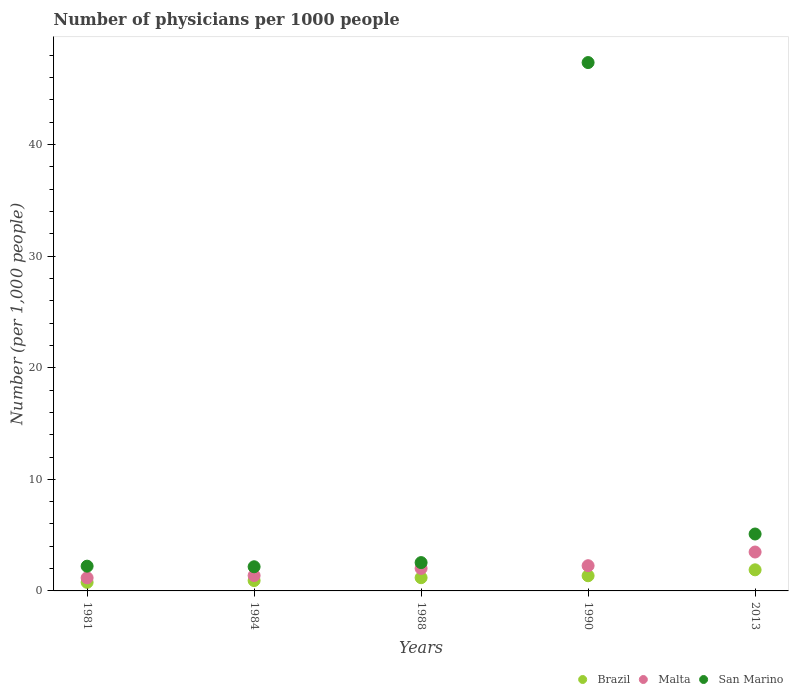Is the number of dotlines equal to the number of legend labels?
Your response must be concise. Yes. What is the number of physicians in San Marino in 1990?
Ensure brevity in your answer.  47.35. Across all years, what is the maximum number of physicians in Brazil?
Provide a short and direct response. 1.89. Across all years, what is the minimum number of physicians in San Marino?
Keep it short and to the point. 2.17. In which year was the number of physicians in Brazil minimum?
Offer a very short reply. 1981. What is the total number of physicians in San Marino in the graph?
Provide a succinct answer. 59.37. What is the difference between the number of physicians in Brazil in 1990 and that in 2013?
Keep it short and to the point. -0.53. What is the difference between the number of physicians in Malta in 1988 and the number of physicians in Brazil in 1981?
Your answer should be compact. 1.25. What is the average number of physicians in Malta per year?
Provide a short and direct response. 2.06. In the year 1988, what is the difference between the number of physicians in Malta and number of physicians in Brazil?
Ensure brevity in your answer.  0.83. What is the ratio of the number of physicians in Malta in 1984 to that in 2013?
Provide a succinct answer. 0.4. Is the number of physicians in San Marino in 1981 less than that in 2013?
Provide a succinct answer. Yes. What is the difference between the highest and the second highest number of physicians in San Marino?
Provide a succinct answer. 42.25. What is the difference between the highest and the lowest number of physicians in Brazil?
Your response must be concise. 1.12. In how many years, is the number of physicians in Malta greater than the average number of physicians in Malta taken over all years?
Offer a terse response. 2. Is the sum of the number of physicians in San Marino in 1988 and 1990 greater than the maximum number of physicians in Brazil across all years?
Keep it short and to the point. Yes. Is it the case that in every year, the sum of the number of physicians in San Marino and number of physicians in Brazil  is greater than the number of physicians in Malta?
Ensure brevity in your answer.  Yes. How many dotlines are there?
Provide a succinct answer. 3. What is the difference between two consecutive major ticks on the Y-axis?
Your response must be concise. 10. Are the values on the major ticks of Y-axis written in scientific E-notation?
Make the answer very short. No. Where does the legend appear in the graph?
Offer a very short reply. Bottom right. How many legend labels are there?
Your answer should be very brief. 3. What is the title of the graph?
Your answer should be compact. Number of physicians per 1000 people. Does "Bolivia" appear as one of the legend labels in the graph?
Provide a succinct answer. No. What is the label or title of the X-axis?
Provide a short and direct response. Years. What is the label or title of the Y-axis?
Provide a succinct answer. Number (per 1,0 people). What is the Number (per 1,000 people) of Brazil in 1981?
Offer a very short reply. 0.77. What is the Number (per 1,000 people) in Malta in 1981?
Offer a very short reply. 1.17. What is the Number (per 1,000 people) of San Marino in 1981?
Give a very brief answer. 2.22. What is the Number (per 1,000 people) in Brazil in 1984?
Your answer should be compact. 0.93. What is the Number (per 1,000 people) in Malta in 1984?
Keep it short and to the point. 1.38. What is the Number (per 1,000 people) of San Marino in 1984?
Provide a short and direct response. 2.17. What is the Number (per 1,000 people) in Brazil in 1988?
Offer a very short reply. 1.19. What is the Number (per 1,000 people) of Malta in 1988?
Your response must be concise. 2.02. What is the Number (per 1,000 people) of San Marino in 1988?
Your answer should be compact. 2.54. What is the Number (per 1,000 people) of Brazil in 1990?
Give a very brief answer. 1.36. What is the Number (per 1,000 people) in Malta in 1990?
Offer a terse response. 2.26. What is the Number (per 1,000 people) in San Marino in 1990?
Provide a succinct answer. 47.35. What is the Number (per 1,000 people) of Brazil in 2013?
Your answer should be compact. 1.89. What is the Number (per 1,000 people) of Malta in 2013?
Your answer should be compact. 3.49. Across all years, what is the maximum Number (per 1,000 people) in Brazil?
Your answer should be compact. 1.89. Across all years, what is the maximum Number (per 1,000 people) of Malta?
Make the answer very short. 3.49. Across all years, what is the maximum Number (per 1,000 people) of San Marino?
Your response must be concise. 47.35. Across all years, what is the minimum Number (per 1,000 people) in Brazil?
Make the answer very short. 0.77. Across all years, what is the minimum Number (per 1,000 people) in Malta?
Provide a short and direct response. 1.17. Across all years, what is the minimum Number (per 1,000 people) in San Marino?
Provide a succinct answer. 2.17. What is the total Number (per 1,000 people) in Brazil in the graph?
Your response must be concise. 6.13. What is the total Number (per 1,000 people) in Malta in the graph?
Your answer should be compact. 10.31. What is the total Number (per 1,000 people) of San Marino in the graph?
Your answer should be very brief. 59.37. What is the difference between the Number (per 1,000 people) of Brazil in 1981 and that in 1984?
Make the answer very short. -0.16. What is the difference between the Number (per 1,000 people) of Malta in 1981 and that in 1984?
Your answer should be very brief. -0.21. What is the difference between the Number (per 1,000 people) of San Marino in 1981 and that in 1984?
Make the answer very short. 0.05. What is the difference between the Number (per 1,000 people) of Brazil in 1981 and that in 1988?
Offer a very short reply. -0.42. What is the difference between the Number (per 1,000 people) of Malta in 1981 and that in 1988?
Provide a short and direct response. -0.84. What is the difference between the Number (per 1,000 people) of San Marino in 1981 and that in 1988?
Offer a terse response. -0.32. What is the difference between the Number (per 1,000 people) of Brazil in 1981 and that in 1990?
Keep it short and to the point. -0.59. What is the difference between the Number (per 1,000 people) of Malta in 1981 and that in 1990?
Provide a short and direct response. -1.09. What is the difference between the Number (per 1,000 people) of San Marino in 1981 and that in 1990?
Provide a succinct answer. -45.13. What is the difference between the Number (per 1,000 people) of Brazil in 1981 and that in 2013?
Your response must be concise. -1.12. What is the difference between the Number (per 1,000 people) in Malta in 1981 and that in 2013?
Provide a short and direct response. -2.31. What is the difference between the Number (per 1,000 people) in San Marino in 1981 and that in 2013?
Provide a succinct answer. -2.88. What is the difference between the Number (per 1,000 people) of Brazil in 1984 and that in 1988?
Provide a short and direct response. -0.26. What is the difference between the Number (per 1,000 people) of Malta in 1984 and that in 1988?
Make the answer very short. -0.64. What is the difference between the Number (per 1,000 people) of San Marino in 1984 and that in 1988?
Offer a terse response. -0.37. What is the difference between the Number (per 1,000 people) in Brazil in 1984 and that in 1990?
Provide a succinct answer. -0.43. What is the difference between the Number (per 1,000 people) of Malta in 1984 and that in 1990?
Provide a succinct answer. -0.88. What is the difference between the Number (per 1,000 people) of San Marino in 1984 and that in 1990?
Your answer should be compact. -45.18. What is the difference between the Number (per 1,000 people) in Brazil in 1984 and that in 2013?
Ensure brevity in your answer.  -0.96. What is the difference between the Number (per 1,000 people) in Malta in 1984 and that in 2013?
Your answer should be very brief. -2.11. What is the difference between the Number (per 1,000 people) of San Marino in 1984 and that in 2013?
Keep it short and to the point. -2.93. What is the difference between the Number (per 1,000 people) in Brazil in 1988 and that in 1990?
Provide a succinct answer. -0.17. What is the difference between the Number (per 1,000 people) in Malta in 1988 and that in 1990?
Provide a short and direct response. -0.24. What is the difference between the Number (per 1,000 people) in San Marino in 1988 and that in 1990?
Your answer should be very brief. -44.81. What is the difference between the Number (per 1,000 people) of Brazil in 1988 and that in 2013?
Give a very brief answer. -0.71. What is the difference between the Number (per 1,000 people) of Malta in 1988 and that in 2013?
Offer a very short reply. -1.47. What is the difference between the Number (per 1,000 people) of San Marino in 1988 and that in 2013?
Your answer should be very brief. -2.56. What is the difference between the Number (per 1,000 people) in Brazil in 1990 and that in 2013?
Ensure brevity in your answer.  -0.53. What is the difference between the Number (per 1,000 people) of Malta in 1990 and that in 2013?
Give a very brief answer. -1.23. What is the difference between the Number (per 1,000 people) in San Marino in 1990 and that in 2013?
Your answer should be very brief. 42.25. What is the difference between the Number (per 1,000 people) in Brazil in 1981 and the Number (per 1,000 people) in Malta in 1984?
Your response must be concise. -0.61. What is the difference between the Number (per 1,000 people) of Brazil in 1981 and the Number (per 1,000 people) of San Marino in 1984?
Make the answer very short. -1.4. What is the difference between the Number (per 1,000 people) of Malta in 1981 and the Number (per 1,000 people) of San Marino in 1984?
Offer a very short reply. -0.99. What is the difference between the Number (per 1,000 people) in Brazil in 1981 and the Number (per 1,000 people) in Malta in 1988?
Make the answer very short. -1.25. What is the difference between the Number (per 1,000 people) in Brazil in 1981 and the Number (per 1,000 people) in San Marino in 1988?
Keep it short and to the point. -1.77. What is the difference between the Number (per 1,000 people) in Malta in 1981 and the Number (per 1,000 people) in San Marino in 1988?
Provide a succinct answer. -1.37. What is the difference between the Number (per 1,000 people) of Brazil in 1981 and the Number (per 1,000 people) of Malta in 1990?
Keep it short and to the point. -1.49. What is the difference between the Number (per 1,000 people) of Brazil in 1981 and the Number (per 1,000 people) of San Marino in 1990?
Your response must be concise. -46.58. What is the difference between the Number (per 1,000 people) of Malta in 1981 and the Number (per 1,000 people) of San Marino in 1990?
Your answer should be compact. -46.18. What is the difference between the Number (per 1,000 people) of Brazil in 1981 and the Number (per 1,000 people) of Malta in 2013?
Your answer should be very brief. -2.72. What is the difference between the Number (per 1,000 people) in Brazil in 1981 and the Number (per 1,000 people) in San Marino in 2013?
Ensure brevity in your answer.  -4.33. What is the difference between the Number (per 1,000 people) in Malta in 1981 and the Number (per 1,000 people) in San Marino in 2013?
Offer a terse response. -3.93. What is the difference between the Number (per 1,000 people) of Brazil in 1984 and the Number (per 1,000 people) of Malta in 1988?
Make the answer very short. -1.09. What is the difference between the Number (per 1,000 people) of Brazil in 1984 and the Number (per 1,000 people) of San Marino in 1988?
Offer a terse response. -1.61. What is the difference between the Number (per 1,000 people) in Malta in 1984 and the Number (per 1,000 people) in San Marino in 1988?
Keep it short and to the point. -1.16. What is the difference between the Number (per 1,000 people) in Brazil in 1984 and the Number (per 1,000 people) in Malta in 1990?
Offer a very short reply. -1.33. What is the difference between the Number (per 1,000 people) in Brazil in 1984 and the Number (per 1,000 people) in San Marino in 1990?
Your answer should be compact. -46.42. What is the difference between the Number (per 1,000 people) of Malta in 1984 and the Number (per 1,000 people) of San Marino in 1990?
Provide a short and direct response. -45.97. What is the difference between the Number (per 1,000 people) in Brazil in 1984 and the Number (per 1,000 people) in Malta in 2013?
Provide a succinct answer. -2.56. What is the difference between the Number (per 1,000 people) of Brazil in 1984 and the Number (per 1,000 people) of San Marino in 2013?
Your answer should be compact. -4.17. What is the difference between the Number (per 1,000 people) in Malta in 1984 and the Number (per 1,000 people) in San Marino in 2013?
Your answer should be compact. -3.72. What is the difference between the Number (per 1,000 people) of Brazil in 1988 and the Number (per 1,000 people) of Malta in 1990?
Keep it short and to the point. -1.07. What is the difference between the Number (per 1,000 people) in Brazil in 1988 and the Number (per 1,000 people) in San Marino in 1990?
Offer a terse response. -46.16. What is the difference between the Number (per 1,000 people) of Malta in 1988 and the Number (per 1,000 people) of San Marino in 1990?
Your response must be concise. -45.34. What is the difference between the Number (per 1,000 people) of Brazil in 1988 and the Number (per 1,000 people) of Malta in 2013?
Your response must be concise. -2.3. What is the difference between the Number (per 1,000 people) of Brazil in 1988 and the Number (per 1,000 people) of San Marino in 2013?
Make the answer very short. -3.91. What is the difference between the Number (per 1,000 people) of Malta in 1988 and the Number (per 1,000 people) of San Marino in 2013?
Give a very brief answer. -3.08. What is the difference between the Number (per 1,000 people) in Brazil in 1990 and the Number (per 1,000 people) in Malta in 2013?
Your answer should be compact. -2.13. What is the difference between the Number (per 1,000 people) in Brazil in 1990 and the Number (per 1,000 people) in San Marino in 2013?
Your answer should be very brief. -3.74. What is the difference between the Number (per 1,000 people) of Malta in 1990 and the Number (per 1,000 people) of San Marino in 2013?
Give a very brief answer. -2.84. What is the average Number (per 1,000 people) of Brazil per year?
Ensure brevity in your answer.  1.23. What is the average Number (per 1,000 people) of Malta per year?
Your response must be concise. 2.06. What is the average Number (per 1,000 people) in San Marino per year?
Offer a very short reply. 11.87. In the year 1981, what is the difference between the Number (per 1,000 people) of Brazil and Number (per 1,000 people) of Malta?
Give a very brief answer. -0.4. In the year 1981, what is the difference between the Number (per 1,000 people) of Brazil and Number (per 1,000 people) of San Marino?
Offer a terse response. -1.45. In the year 1981, what is the difference between the Number (per 1,000 people) of Malta and Number (per 1,000 people) of San Marino?
Provide a succinct answer. -1.05. In the year 1984, what is the difference between the Number (per 1,000 people) of Brazil and Number (per 1,000 people) of Malta?
Keep it short and to the point. -0.45. In the year 1984, what is the difference between the Number (per 1,000 people) in Brazil and Number (per 1,000 people) in San Marino?
Your response must be concise. -1.24. In the year 1984, what is the difference between the Number (per 1,000 people) in Malta and Number (per 1,000 people) in San Marino?
Your answer should be very brief. -0.79. In the year 1988, what is the difference between the Number (per 1,000 people) of Brazil and Number (per 1,000 people) of Malta?
Make the answer very short. -0.83. In the year 1988, what is the difference between the Number (per 1,000 people) in Brazil and Number (per 1,000 people) in San Marino?
Give a very brief answer. -1.35. In the year 1988, what is the difference between the Number (per 1,000 people) of Malta and Number (per 1,000 people) of San Marino?
Keep it short and to the point. -0.52. In the year 1990, what is the difference between the Number (per 1,000 people) in Brazil and Number (per 1,000 people) in Malta?
Make the answer very short. -0.9. In the year 1990, what is the difference between the Number (per 1,000 people) in Brazil and Number (per 1,000 people) in San Marino?
Ensure brevity in your answer.  -45.99. In the year 1990, what is the difference between the Number (per 1,000 people) in Malta and Number (per 1,000 people) in San Marino?
Provide a short and direct response. -45.09. In the year 2013, what is the difference between the Number (per 1,000 people) of Brazil and Number (per 1,000 people) of Malta?
Give a very brief answer. -1.59. In the year 2013, what is the difference between the Number (per 1,000 people) in Brazil and Number (per 1,000 people) in San Marino?
Keep it short and to the point. -3.21. In the year 2013, what is the difference between the Number (per 1,000 people) of Malta and Number (per 1,000 people) of San Marino?
Provide a short and direct response. -1.61. What is the ratio of the Number (per 1,000 people) in Brazil in 1981 to that in 1984?
Provide a short and direct response. 0.83. What is the ratio of the Number (per 1,000 people) of Malta in 1981 to that in 1984?
Your response must be concise. 0.85. What is the ratio of the Number (per 1,000 people) of Brazil in 1981 to that in 1988?
Keep it short and to the point. 0.65. What is the ratio of the Number (per 1,000 people) of Malta in 1981 to that in 1988?
Your response must be concise. 0.58. What is the ratio of the Number (per 1,000 people) in San Marino in 1981 to that in 1988?
Your response must be concise. 0.87. What is the ratio of the Number (per 1,000 people) in Brazil in 1981 to that in 1990?
Your answer should be compact. 0.56. What is the ratio of the Number (per 1,000 people) in Malta in 1981 to that in 1990?
Give a very brief answer. 0.52. What is the ratio of the Number (per 1,000 people) of San Marino in 1981 to that in 1990?
Your answer should be compact. 0.05. What is the ratio of the Number (per 1,000 people) in Brazil in 1981 to that in 2013?
Make the answer very short. 0.41. What is the ratio of the Number (per 1,000 people) in Malta in 1981 to that in 2013?
Make the answer very short. 0.34. What is the ratio of the Number (per 1,000 people) in San Marino in 1981 to that in 2013?
Give a very brief answer. 0.43. What is the ratio of the Number (per 1,000 people) in Brazil in 1984 to that in 1988?
Your answer should be very brief. 0.78. What is the ratio of the Number (per 1,000 people) in Malta in 1984 to that in 1988?
Give a very brief answer. 0.68. What is the ratio of the Number (per 1,000 people) of San Marino in 1984 to that in 1988?
Ensure brevity in your answer.  0.85. What is the ratio of the Number (per 1,000 people) of Brazil in 1984 to that in 1990?
Give a very brief answer. 0.68. What is the ratio of the Number (per 1,000 people) in Malta in 1984 to that in 1990?
Ensure brevity in your answer.  0.61. What is the ratio of the Number (per 1,000 people) of San Marino in 1984 to that in 1990?
Offer a very short reply. 0.05. What is the ratio of the Number (per 1,000 people) in Brazil in 1984 to that in 2013?
Keep it short and to the point. 0.49. What is the ratio of the Number (per 1,000 people) in Malta in 1984 to that in 2013?
Offer a terse response. 0.4. What is the ratio of the Number (per 1,000 people) of San Marino in 1984 to that in 2013?
Your response must be concise. 0.42. What is the ratio of the Number (per 1,000 people) in Brazil in 1988 to that in 1990?
Offer a very short reply. 0.87. What is the ratio of the Number (per 1,000 people) in Malta in 1988 to that in 1990?
Give a very brief answer. 0.89. What is the ratio of the Number (per 1,000 people) of San Marino in 1988 to that in 1990?
Your answer should be compact. 0.05. What is the ratio of the Number (per 1,000 people) in Brazil in 1988 to that in 2013?
Make the answer very short. 0.63. What is the ratio of the Number (per 1,000 people) of Malta in 1988 to that in 2013?
Provide a short and direct response. 0.58. What is the ratio of the Number (per 1,000 people) of San Marino in 1988 to that in 2013?
Your response must be concise. 0.5. What is the ratio of the Number (per 1,000 people) of Brazil in 1990 to that in 2013?
Provide a succinct answer. 0.72. What is the ratio of the Number (per 1,000 people) of Malta in 1990 to that in 2013?
Your answer should be compact. 0.65. What is the ratio of the Number (per 1,000 people) in San Marino in 1990 to that in 2013?
Provide a succinct answer. 9.28. What is the difference between the highest and the second highest Number (per 1,000 people) of Brazil?
Your answer should be compact. 0.53. What is the difference between the highest and the second highest Number (per 1,000 people) of Malta?
Offer a very short reply. 1.23. What is the difference between the highest and the second highest Number (per 1,000 people) of San Marino?
Ensure brevity in your answer.  42.25. What is the difference between the highest and the lowest Number (per 1,000 people) in Brazil?
Your answer should be compact. 1.12. What is the difference between the highest and the lowest Number (per 1,000 people) in Malta?
Provide a short and direct response. 2.31. What is the difference between the highest and the lowest Number (per 1,000 people) of San Marino?
Make the answer very short. 45.18. 